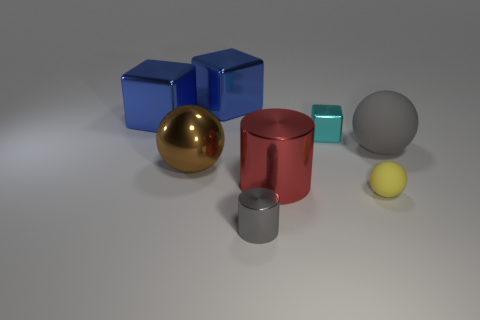How many blue cubes must be subtracted to get 1 blue cubes? 1 Subtract all tiny spheres. How many spheres are left? 2 Subtract 1 cubes. How many cubes are left? 2 Add 1 large red shiny cylinders. How many objects exist? 9 Subtract all blocks. How many objects are left? 5 Subtract all small metal cubes. Subtract all big brown metallic spheres. How many objects are left? 6 Add 8 brown balls. How many brown balls are left? 9 Add 6 blocks. How many blocks exist? 9 Subtract 0 cyan spheres. How many objects are left? 8 